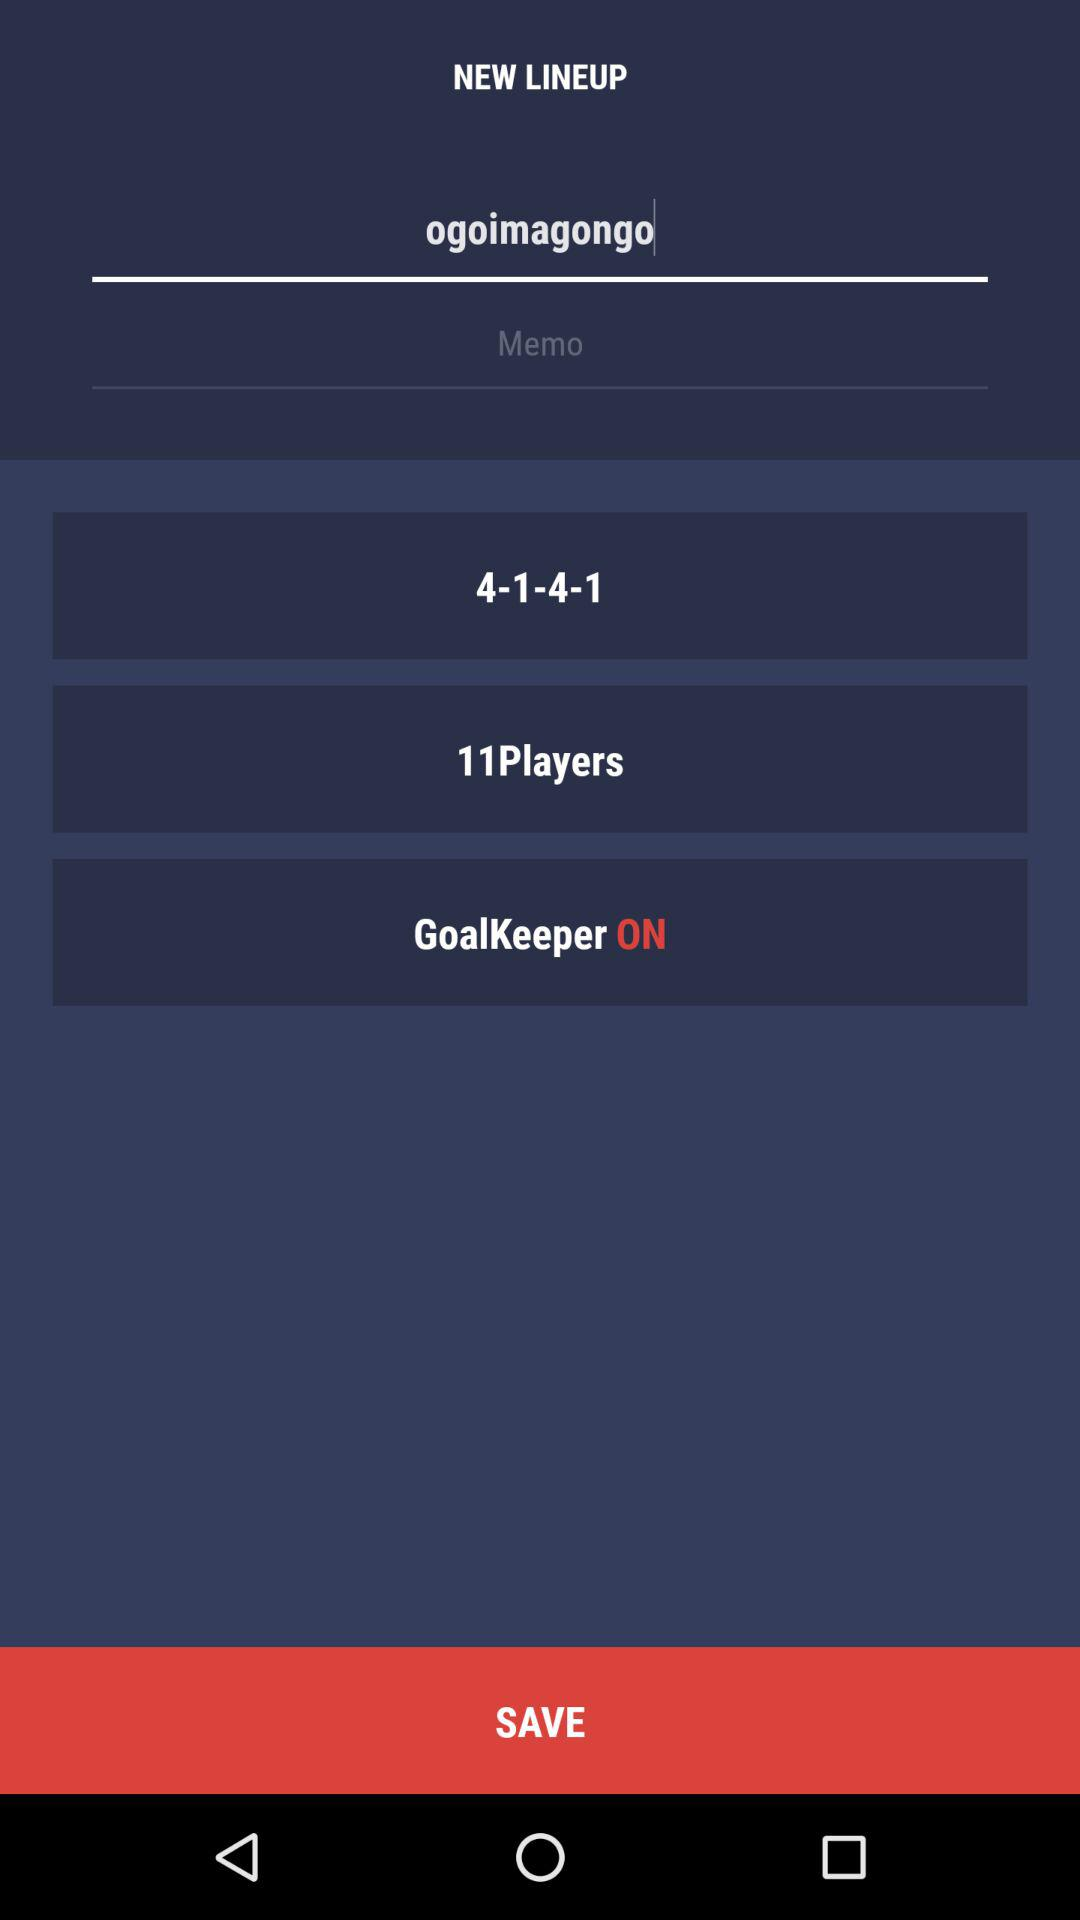Is the new lineup saved?
When the provided information is insufficient, respond with <no answer>. <no answer> 